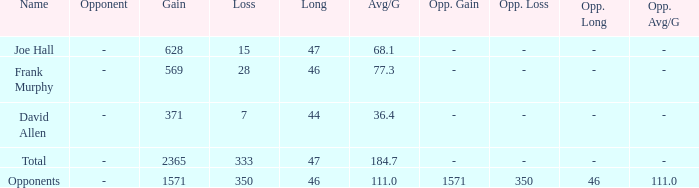Could you parse the entire table as a dict? {'header': ['Name', 'Opponent', 'Gain', 'Loss', 'Long', 'Avg/G', 'Opp. Gain', 'Opp. Loss', 'Opp. Long', 'Opp. Avg/G'], 'rows': [['Joe Hall', '-', '628', '15', '47', '68.1', '-', '-', '-', '-'], ['Frank Murphy', '-', '569', '28', '46', '77.3', '-', '-', '-', '-'], ['David Allen', '-', '371', '7', '44', '36.4', '-', '-', '-', '-'], ['Total', '-', '2365', '333', '47', '184.7', '-', '-', '-', '-'], ['Opponents', '-', '1571', '350', '46', '111.0', '1571', '350', '46', '111.0']]} How much Loss has a Gain smaller than 1571, and a Long smaller than 47, and an Avg/G of 36.4? 1.0. 